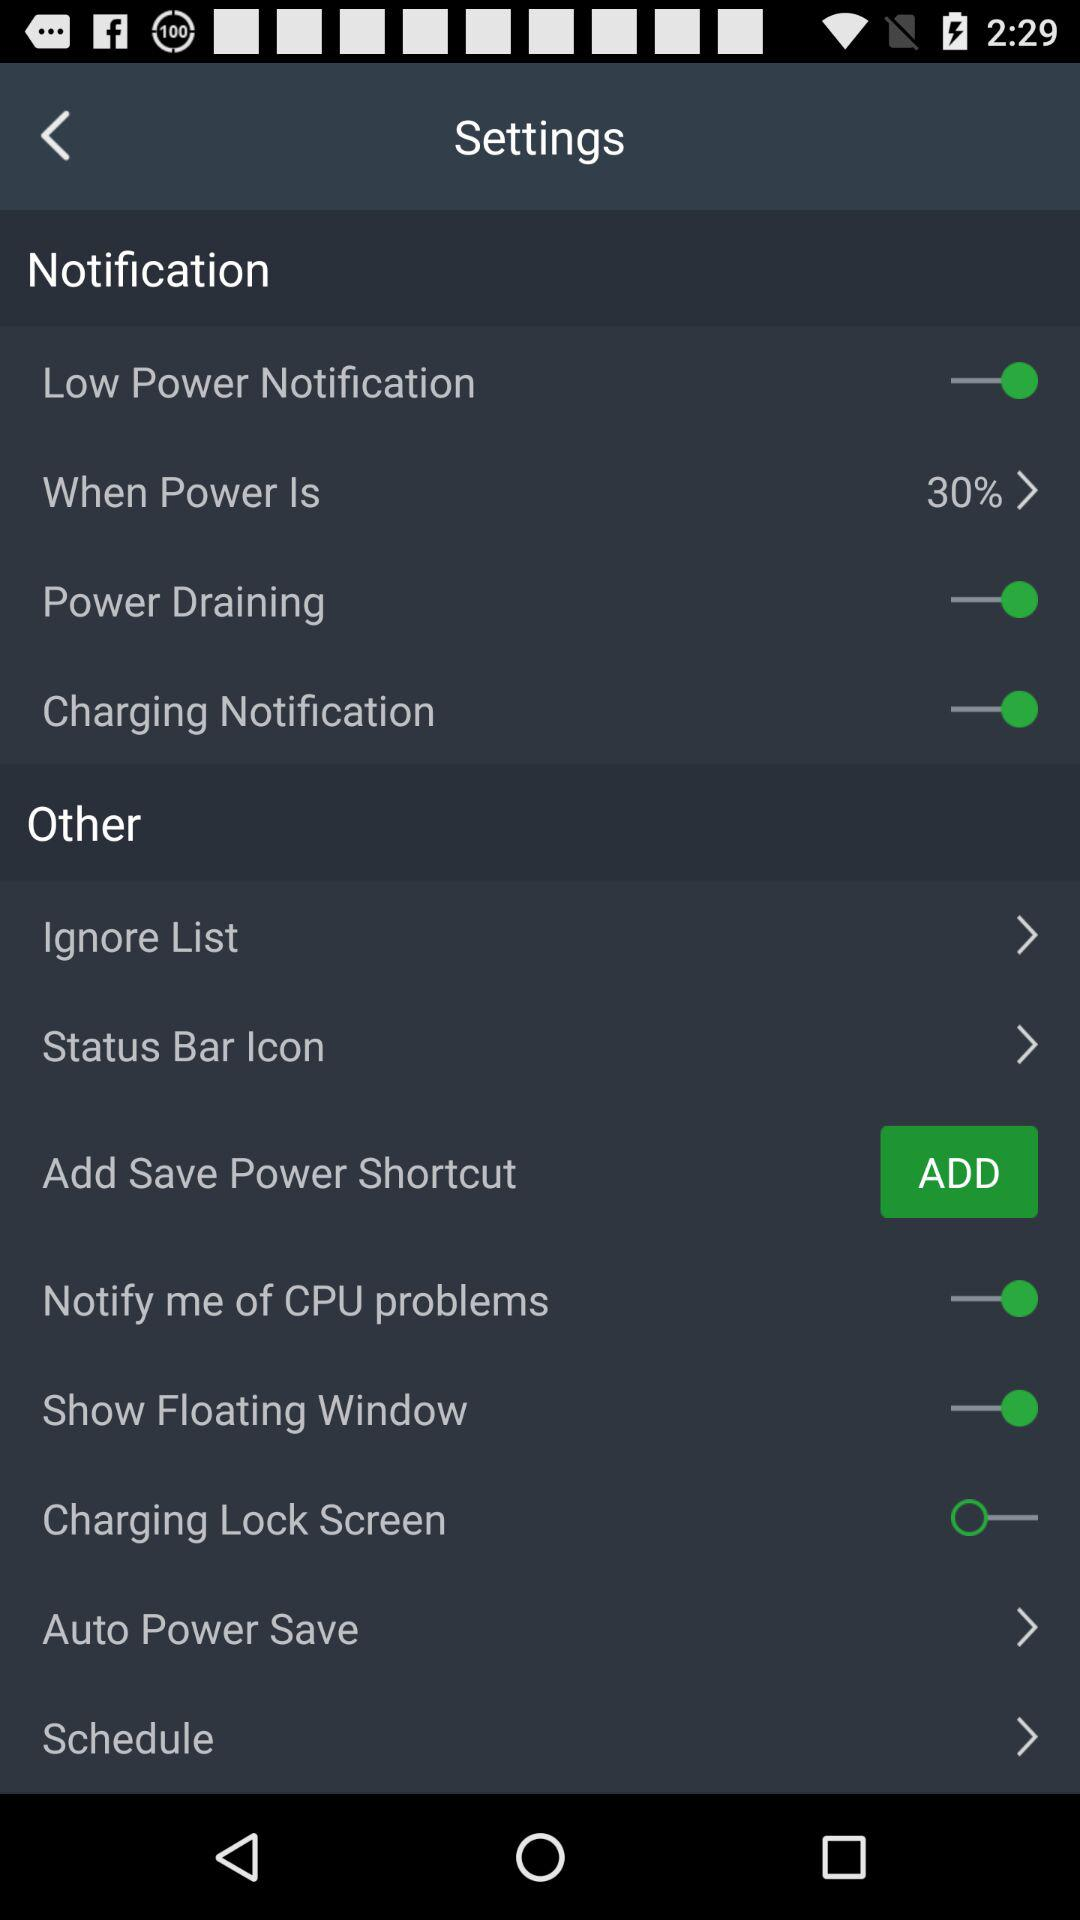What is the status of the "Charging Notification"? The status is "on". 